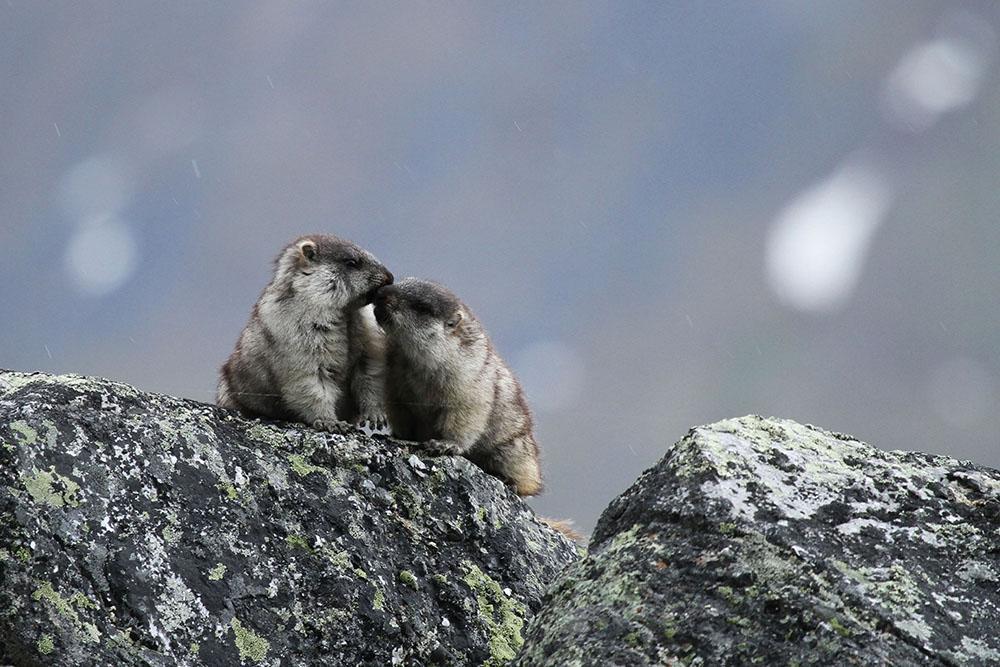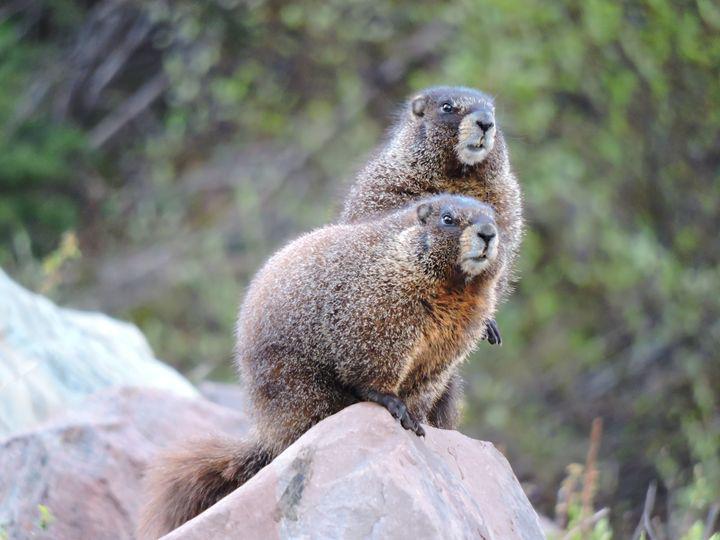The first image is the image on the left, the second image is the image on the right. Considering the images on both sides, is "Each image contains one pair of marmots posed close together on a rock, and no marmots have their backs to the camera." valid? Answer yes or no. Yes. The first image is the image on the left, the second image is the image on the right. Evaluate the accuracy of this statement regarding the images: "On the right image, the two animals are facing the same direction.". Is it true? Answer yes or no. Yes. 